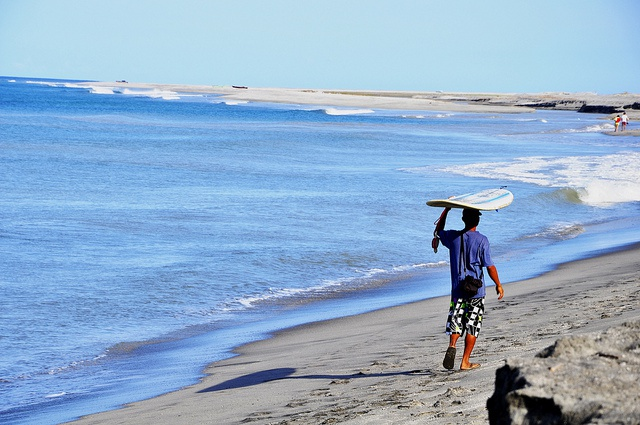Describe the objects in this image and their specific colors. I can see people in lightblue, black, blue, navy, and gray tones, surfboard in lightblue, lightgray, and black tones, and people in lightblue, white, darkgray, gray, and maroon tones in this image. 